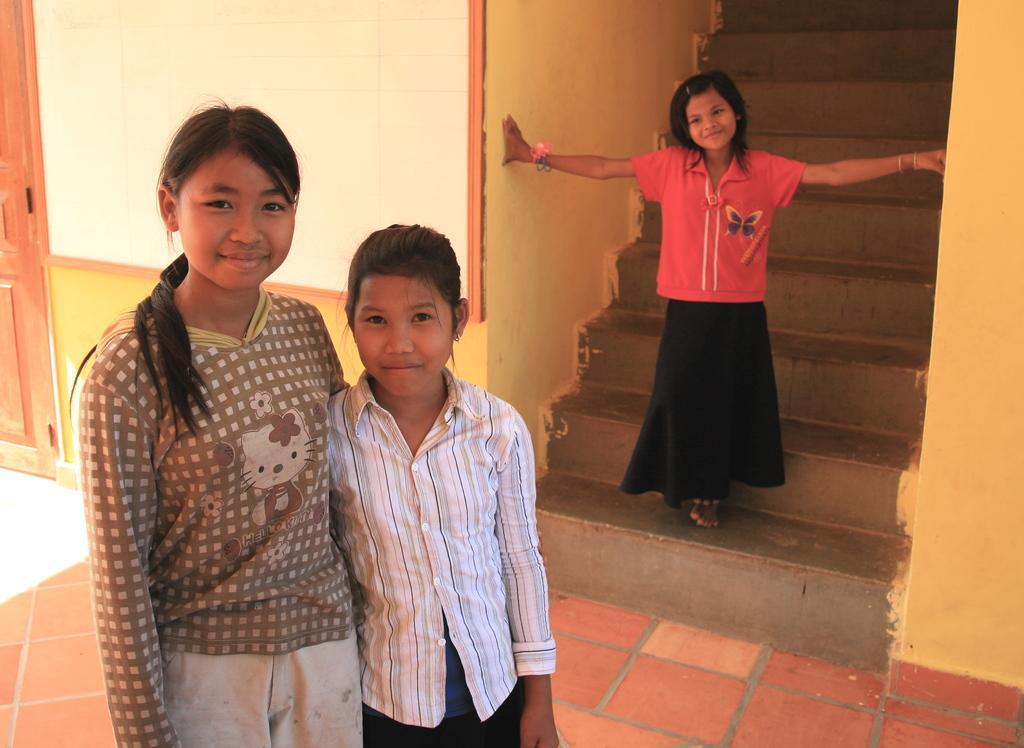Please provide a concise description of this image. In this image we can see kids. There are staircase. To the left side of the image there is wall. At the bottom of the image there is floor. 